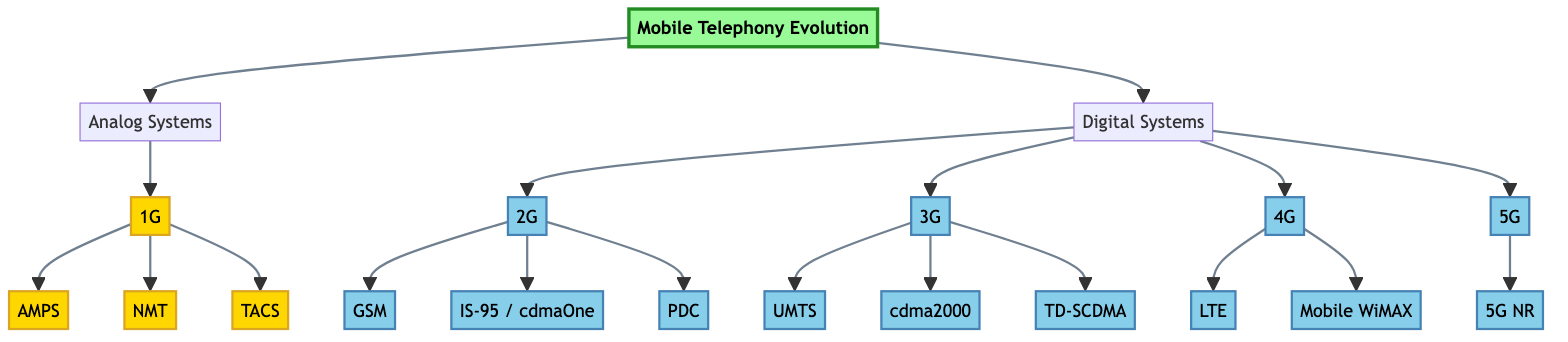What's the root node of the diagram? The root node is the starting point of the diagram, which represents the overall topic of the hierarchal structure. In this case, it is "Mobile Telephony Evolution."
Answer: Mobile Telephony Evolution How many main categories are there in the diagram? The diagram has two main categories: "Analog Systems" and "Digital Systems." These categories are directly connected to the root node.
Answer: 2 What is the first generation of mobile telephony? The first generation, as depicted in the diagram, is represented by the node "1G," which focuses on analog systems.
Answer: 1G How many technologies are listed under 2G? The node for "2G" indicates three technologies listed beneath it: "GSM," "IS-95 / cdmaOne," and "PDC." Count each of these unique technologies for the answer.
Answer: 3 Which technology is under the 4G category? The diagram shows two technologies under the "4G" category, and one of them is "Long Term Evolution (LTE)."
Answer: Long Term Evolution (LTE) What is the relationship between 3G and 4G? "3G" is a category directly connected to "4G," indicating that 4G is a subsequent generation that follows 3G in the evolution of mobile telephony standards.
Answer: Subsequent Which system has the least number of technologies listed? The "5G" category contains only one technology, which is "5G New Radio (NR)," making it the system with the least number of technologies listed.
Answer: 5G New Radio (NR) What is the total number of technologies presented in the digital systems category? To find the total technologies, count the technologies under each digital generation (2G, 3G, 4G, 5G) and add them up: 3 from 2G, 3 from 3G, 2 from 4G, and 1 from 5G, resulting in a total of 9.
Answer: 9 Which generation does the "AMPS" technology belong to? "AMPS" is listed under the "1G" category, representing the first generation of mobile telephony systems.
Answer: 1G What is the last node in the diagram? The diagram culminates at "5G New Radio (NR)" under the "5G" category, making it the final node in the structure.
Answer: 5G New Radio (NR) 